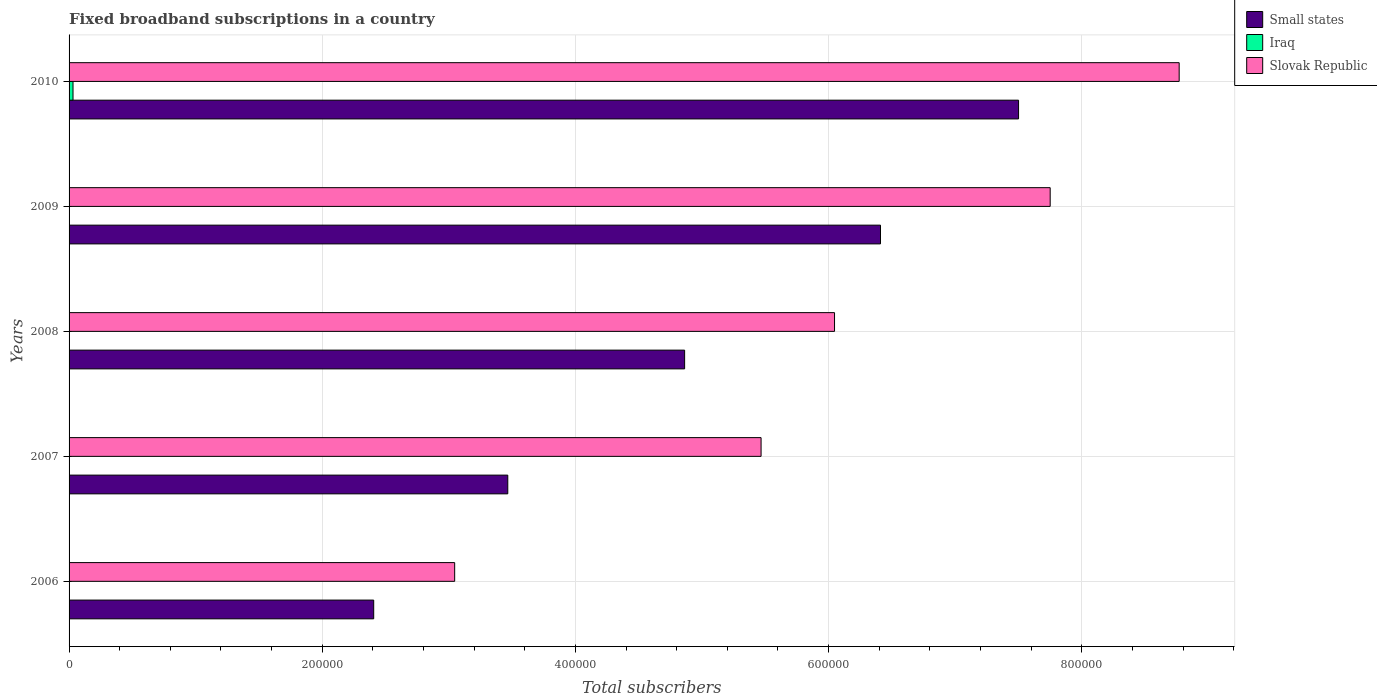How many different coloured bars are there?
Keep it short and to the point. 3. How many groups of bars are there?
Give a very brief answer. 5. Are the number of bars per tick equal to the number of legend labels?
Offer a terse response. Yes. What is the label of the 1st group of bars from the top?
Your response must be concise. 2010. In how many cases, is the number of bars for a given year not equal to the number of legend labels?
Your response must be concise. 0. What is the number of broadband subscriptions in Iraq in 2007?
Your answer should be compact. 98. Across all years, what is the maximum number of broadband subscriptions in Slovak Republic?
Make the answer very short. 8.77e+05. Across all years, what is the minimum number of broadband subscriptions in Slovak Republic?
Provide a succinct answer. 3.05e+05. In which year was the number of broadband subscriptions in Iraq maximum?
Provide a short and direct response. 2010. What is the total number of broadband subscriptions in Small states in the graph?
Make the answer very short. 2.46e+06. What is the difference between the number of broadband subscriptions in Slovak Republic in 2009 and that in 2010?
Your answer should be compact. -1.02e+05. What is the difference between the number of broadband subscriptions in Iraq in 2008 and the number of broadband subscriptions in Slovak Republic in 2007?
Offer a very short reply. -5.47e+05. What is the average number of broadband subscriptions in Iraq per year?
Your answer should be very brief. 683.2. In the year 2010, what is the difference between the number of broadband subscriptions in Slovak Republic and number of broadband subscriptions in Iraq?
Offer a terse response. 8.74e+05. In how many years, is the number of broadband subscriptions in Iraq greater than 880000 ?
Give a very brief answer. 0. What is the ratio of the number of broadband subscriptions in Iraq in 2006 to that in 2007?
Ensure brevity in your answer.  0.27. Is the difference between the number of broadband subscriptions in Slovak Republic in 2007 and 2009 greater than the difference between the number of broadband subscriptions in Iraq in 2007 and 2009?
Your answer should be compact. No. What is the difference between the highest and the second highest number of broadband subscriptions in Iraq?
Ensure brevity in your answer.  2996. What is the difference between the highest and the lowest number of broadband subscriptions in Iraq?
Keep it short and to the point. 3091. Is the sum of the number of broadband subscriptions in Slovak Republic in 2007 and 2008 greater than the maximum number of broadband subscriptions in Iraq across all years?
Offer a terse response. Yes. What does the 3rd bar from the top in 2006 represents?
Offer a terse response. Small states. What does the 3rd bar from the bottom in 2006 represents?
Offer a very short reply. Slovak Republic. How many years are there in the graph?
Your answer should be compact. 5. What is the difference between two consecutive major ticks on the X-axis?
Your response must be concise. 2.00e+05. Does the graph contain grids?
Offer a terse response. Yes. How many legend labels are there?
Offer a terse response. 3. What is the title of the graph?
Your answer should be compact. Fixed broadband subscriptions in a country. Does "Guinea-Bissau" appear as one of the legend labels in the graph?
Make the answer very short. No. What is the label or title of the X-axis?
Your response must be concise. Total subscribers. What is the Total subscribers of Small states in 2006?
Provide a short and direct response. 2.41e+05. What is the Total subscribers of Slovak Republic in 2006?
Give a very brief answer. 3.05e+05. What is the Total subscribers in Small states in 2007?
Offer a terse response. 3.47e+05. What is the Total subscribers of Iraq in 2007?
Provide a succinct answer. 98. What is the Total subscribers of Slovak Republic in 2007?
Provide a short and direct response. 5.47e+05. What is the Total subscribers in Small states in 2008?
Offer a terse response. 4.86e+05. What is the Total subscribers in Iraq in 2008?
Provide a succinct answer. 54. What is the Total subscribers in Slovak Republic in 2008?
Offer a very short reply. 6.05e+05. What is the Total subscribers of Small states in 2009?
Your answer should be compact. 6.41e+05. What is the Total subscribers of Iraq in 2009?
Your answer should be very brief. 121. What is the Total subscribers of Slovak Republic in 2009?
Keep it short and to the point. 7.75e+05. What is the Total subscribers of Small states in 2010?
Give a very brief answer. 7.50e+05. What is the Total subscribers in Iraq in 2010?
Offer a terse response. 3117. What is the Total subscribers of Slovak Republic in 2010?
Provide a succinct answer. 8.77e+05. Across all years, what is the maximum Total subscribers in Small states?
Your answer should be compact. 7.50e+05. Across all years, what is the maximum Total subscribers in Iraq?
Provide a succinct answer. 3117. Across all years, what is the maximum Total subscribers of Slovak Republic?
Your response must be concise. 8.77e+05. Across all years, what is the minimum Total subscribers in Small states?
Your answer should be very brief. 2.41e+05. Across all years, what is the minimum Total subscribers in Slovak Republic?
Provide a short and direct response. 3.05e+05. What is the total Total subscribers in Small states in the graph?
Your answer should be compact. 2.46e+06. What is the total Total subscribers in Iraq in the graph?
Your response must be concise. 3416. What is the total Total subscribers of Slovak Republic in the graph?
Provide a short and direct response. 3.11e+06. What is the difference between the Total subscribers of Small states in 2006 and that in 2007?
Provide a succinct answer. -1.06e+05. What is the difference between the Total subscribers in Iraq in 2006 and that in 2007?
Your answer should be very brief. -72. What is the difference between the Total subscribers in Slovak Republic in 2006 and that in 2007?
Your response must be concise. -2.42e+05. What is the difference between the Total subscribers of Small states in 2006 and that in 2008?
Provide a short and direct response. -2.46e+05. What is the difference between the Total subscribers of Iraq in 2006 and that in 2008?
Provide a succinct answer. -28. What is the difference between the Total subscribers of Slovak Republic in 2006 and that in 2008?
Your answer should be very brief. -3.00e+05. What is the difference between the Total subscribers of Small states in 2006 and that in 2009?
Keep it short and to the point. -4.00e+05. What is the difference between the Total subscribers in Iraq in 2006 and that in 2009?
Make the answer very short. -95. What is the difference between the Total subscribers of Slovak Republic in 2006 and that in 2009?
Provide a short and direct response. -4.70e+05. What is the difference between the Total subscribers of Small states in 2006 and that in 2010?
Provide a succinct answer. -5.09e+05. What is the difference between the Total subscribers in Iraq in 2006 and that in 2010?
Keep it short and to the point. -3091. What is the difference between the Total subscribers in Slovak Republic in 2006 and that in 2010?
Your answer should be very brief. -5.72e+05. What is the difference between the Total subscribers in Small states in 2007 and that in 2008?
Give a very brief answer. -1.40e+05. What is the difference between the Total subscribers in Iraq in 2007 and that in 2008?
Provide a succinct answer. 44. What is the difference between the Total subscribers of Slovak Republic in 2007 and that in 2008?
Make the answer very short. -5.80e+04. What is the difference between the Total subscribers of Small states in 2007 and that in 2009?
Make the answer very short. -2.94e+05. What is the difference between the Total subscribers in Iraq in 2007 and that in 2009?
Offer a terse response. -23. What is the difference between the Total subscribers in Slovak Republic in 2007 and that in 2009?
Your response must be concise. -2.28e+05. What is the difference between the Total subscribers in Small states in 2007 and that in 2010?
Your answer should be very brief. -4.04e+05. What is the difference between the Total subscribers in Iraq in 2007 and that in 2010?
Keep it short and to the point. -3019. What is the difference between the Total subscribers in Slovak Republic in 2007 and that in 2010?
Provide a short and direct response. -3.30e+05. What is the difference between the Total subscribers in Small states in 2008 and that in 2009?
Offer a very short reply. -1.55e+05. What is the difference between the Total subscribers of Iraq in 2008 and that in 2009?
Offer a terse response. -67. What is the difference between the Total subscribers of Slovak Republic in 2008 and that in 2009?
Offer a terse response. -1.70e+05. What is the difference between the Total subscribers of Small states in 2008 and that in 2010?
Provide a short and direct response. -2.64e+05. What is the difference between the Total subscribers in Iraq in 2008 and that in 2010?
Give a very brief answer. -3063. What is the difference between the Total subscribers in Slovak Republic in 2008 and that in 2010?
Provide a short and direct response. -2.72e+05. What is the difference between the Total subscribers in Small states in 2009 and that in 2010?
Make the answer very short. -1.09e+05. What is the difference between the Total subscribers of Iraq in 2009 and that in 2010?
Give a very brief answer. -2996. What is the difference between the Total subscribers in Slovak Republic in 2009 and that in 2010?
Offer a terse response. -1.02e+05. What is the difference between the Total subscribers in Small states in 2006 and the Total subscribers in Iraq in 2007?
Provide a succinct answer. 2.41e+05. What is the difference between the Total subscribers in Small states in 2006 and the Total subscribers in Slovak Republic in 2007?
Give a very brief answer. -3.06e+05. What is the difference between the Total subscribers in Iraq in 2006 and the Total subscribers in Slovak Republic in 2007?
Your response must be concise. -5.47e+05. What is the difference between the Total subscribers in Small states in 2006 and the Total subscribers in Iraq in 2008?
Your answer should be compact. 2.41e+05. What is the difference between the Total subscribers of Small states in 2006 and the Total subscribers of Slovak Republic in 2008?
Ensure brevity in your answer.  -3.64e+05. What is the difference between the Total subscribers in Iraq in 2006 and the Total subscribers in Slovak Republic in 2008?
Your answer should be very brief. -6.05e+05. What is the difference between the Total subscribers of Small states in 2006 and the Total subscribers of Iraq in 2009?
Offer a terse response. 2.41e+05. What is the difference between the Total subscribers of Small states in 2006 and the Total subscribers of Slovak Republic in 2009?
Give a very brief answer. -5.34e+05. What is the difference between the Total subscribers in Iraq in 2006 and the Total subscribers in Slovak Republic in 2009?
Your response must be concise. -7.75e+05. What is the difference between the Total subscribers of Small states in 2006 and the Total subscribers of Iraq in 2010?
Give a very brief answer. 2.38e+05. What is the difference between the Total subscribers of Small states in 2006 and the Total subscribers of Slovak Republic in 2010?
Provide a succinct answer. -6.36e+05. What is the difference between the Total subscribers of Iraq in 2006 and the Total subscribers of Slovak Republic in 2010?
Provide a succinct answer. -8.77e+05. What is the difference between the Total subscribers in Small states in 2007 and the Total subscribers in Iraq in 2008?
Your answer should be very brief. 3.47e+05. What is the difference between the Total subscribers in Small states in 2007 and the Total subscribers in Slovak Republic in 2008?
Your answer should be very brief. -2.58e+05. What is the difference between the Total subscribers in Iraq in 2007 and the Total subscribers in Slovak Republic in 2008?
Your answer should be compact. -6.05e+05. What is the difference between the Total subscribers of Small states in 2007 and the Total subscribers of Iraq in 2009?
Your response must be concise. 3.46e+05. What is the difference between the Total subscribers in Small states in 2007 and the Total subscribers in Slovak Republic in 2009?
Your answer should be compact. -4.28e+05. What is the difference between the Total subscribers of Iraq in 2007 and the Total subscribers of Slovak Republic in 2009?
Make the answer very short. -7.75e+05. What is the difference between the Total subscribers in Small states in 2007 and the Total subscribers in Iraq in 2010?
Provide a succinct answer. 3.43e+05. What is the difference between the Total subscribers in Small states in 2007 and the Total subscribers in Slovak Republic in 2010?
Offer a very short reply. -5.30e+05. What is the difference between the Total subscribers in Iraq in 2007 and the Total subscribers in Slovak Republic in 2010?
Make the answer very short. -8.77e+05. What is the difference between the Total subscribers of Small states in 2008 and the Total subscribers of Iraq in 2009?
Provide a succinct answer. 4.86e+05. What is the difference between the Total subscribers of Small states in 2008 and the Total subscribers of Slovak Republic in 2009?
Keep it short and to the point. -2.89e+05. What is the difference between the Total subscribers in Iraq in 2008 and the Total subscribers in Slovak Republic in 2009?
Your answer should be very brief. -7.75e+05. What is the difference between the Total subscribers in Small states in 2008 and the Total subscribers in Iraq in 2010?
Your response must be concise. 4.83e+05. What is the difference between the Total subscribers of Small states in 2008 and the Total subscribers of Slovak Republic in 2010?
Keep it short and to the point. -3.91e+05. What is the difference between the Total subscribers of Iraq in 2008 and the Total subscribers of Slovak Republic in 2010?
Keep it short and to the point. -8.77e+05. What is the difference between the Total subscribers of Small states in 2009 and the Total subscribers of Iraq in 2010?
Ensure brevity in your answer.  6.38e+05. What is the difference between the Total subscribers in Small states in 2009 and the Total subscribers in Slovak Republic in 2010?
Provide a short and direct response. -2.36e+05. What is the difference between the Total subscribers in Iraq in 2009 and the Total subscribers in Slovak Republic in 2010?
Your answer should be compact. -8.77e+05. What is the average Total subscribers in Small states per year?
Provide a succinct answer. 4.93e+05. What is the average Total subscribers of Iraq per year?
Make the answer very short. 683.2. What is the average Total subscribers of Slovak Republic per year?
Provide a succinct answer. 6.22e+05. In the year 2006, what is the difference between the Total subscribers in Small states and Total subscribers in Iraq?
Your response must be concise. 2.41e+05. In the year 2006, what is the difference between the Total subscribers of Small states and Total subscribers of Slovak Republic?
Provide a short and direct response. -6.40e+04. In the year 2006, what is the difference between the Total subscribers in Iraq and Total subscribers in Slovak Republic?
Offer a very short reply. -3.05e+05. In the year 2007, what is the difference between the Total subscribers in Small states and Total subscribers in Iraq?
Your response must be concise. 3.46e+05. In the year 2007, what is the difference between the Total subscribers of Small states and Total subscribers of Slovak Republic?
Offer a terse response. -2.00e+05. In the year 2007, what is the difference between the Total subscribers of Iraq and Total subscribers of Slovak Republic?
Offer a terse response. -5.47e+05. In the year 2008, what is the difference between the Total subscribers in Small states and Total subscribers in Iraq?
Provide a short and direct response. 4.86e+05. In the year 2008, what is the difference between the Total subscribers of Small states and Total subscribers of Slovak Republic?
Provide a succinct answer. -1.18e+05. In the year 2008, what is the difference between the Total subscribers of Iraq and Total subscribers of Slovak Republic?
Provide a short and direct response. -6.05e+05. In the year 2009, what is the difference between the Total subscribers in Small states and Total subscribers in Iraq?
Offer a terse response. 6.41e+05. In the year 2009, what is the difference between the Total subscribers in Small states and Total subscribers in Slovak Republic?
Provide a succinct answer. -1.34e+05. In the year 2009, what is the difference between the Total subscribers of Iraq and Total subscribers of Slovak Republic?
Your answer should be compact. -7.75e+05. In the year 2010, what is the difference between the Total subscribers of Small states and Total subscribers of Iraq?
Your answer should be very brief. 7.47e+05. In the year 2010, what is the difference between the Total subscribers in Small states and Total subscribers in Slovak Republic?
Give a very brief answer. -1.27e+05. In the year 2010, what is the difference between the Total subscribers in Iraq and Total subscribers in Slovak Republic?
Keep it short and to the point. -8.74e+05. What is the ratio of the Total subscribers in Small states in 2006 to that in 2007?
Make the answer very short. 0.69. What is the ratio of the Total subscribers in Iraq in 2006 to that in 2007?
Make the answer very short. 0.27. What is the ratio of the Total subscribers in Slovak Republic in 2006 to that in 2007?
Provide a short and direct response. 0.56. What is the ratio of the Total subscribers of Small states in 2006 to that in 2008?
Give a very brief answer. 0.49. What is the ratio of the Total subscribers of Iraq in 2006 to that in 2008?
Provide a succinct answer. 0.48. What is the ratio of the Total subscribers in Slovak Republic in 2006 to that in 2008?
Your answer should be compact. 0.5. What is the ratio of the Total subscribers of Small states in 2006 to that in 2009?
Offer a very short reply. 0.38. What is the ratio of the Total subscribers in Iraq in 2006 to that in 2009?
Your response must be concise. 0.21. What is the ratio of the Total subscribers in Slovak Republic in 2006 to that in 2009?
Your response must be concise. 0.39. What is the ratio of the Total subscribers of Small states in 2006 to that in 2010?
Give a very brief answer. 0.32. What is the ratio of the Total subscribers in Iraq in 2006 to that in 2010?
Offer a terse response. 0.01. What is the ratio of the Total subscribers of Slovak Republic in 2006 to that in 2010?
Your response must be concise. 0.35. What is the ratio of the Total subscribers in Small states in 2007 to that in 2008?
Provide a short and direct response. 0.71. What is the ratio of the Total subscribers of Iraq in 2007 to that in 2008?
Keep it short and to the point. 1.81. What is the ratio of the Total subscribers of Slovak Republic in 2007 to that in 2008?
Your answer should be very brief. 0.9. What is the ratio of the Total subscribers of Small states in 2007 to that in 2009?
Your answer should be compact. 0.54. What is the ratio of the Total subscribers of Iraq in 2007 to that in 2009?
Your response must be concise. 0.81. What is the ratio of the Total subscribers in Slovak Republic in 2007 to that in 2009?
Offer a very short reply. 0.71. What is the ratio of the Total subscribers of Small states in 2007 to that in 2010?
Offer a very short reply. 0.46. What is the ratio of the Total subscribers of Iraq in 2007 to that in 2010?
Ensure brevity in your answer.  0.03. What is the ratio of the Total subscribers in Slovak Republic in 2007 to that in 2010?
Give a very brief answer. 0.62. What is the ratio of the Total subscribers of Small states in 2008 to that in 2009?
Your response must be concise. 0.76. What is the ratio of the Total subscribers of Iraq in 2008 to that in 2009?
Provide a short and direct response. 0.45. What is the ratio of the Total subscribers of Slovak Republic in 2008 to that in 2009?
Your answer should be compact. 0.78. What is the ratio of the Total subscribers of Small states in 2008 to that in 2010?
Your response must be concise. 0.65. What is the ratio of the Total subscribers in Iraq in 2008 to that in 2010?
Offer a very short reply. 0.02. What is the ratio of the Total subscribers in Slovak Republic in 2008 to that in 2010?
Provide a succinct answer. 0.69. What is the ratio of the Total subscribers of Small states in 2009 to that in 2010?
Offer a very short reply. 0.85. What is the ratio of the Total subscribers of Iraq in 2009 to that in 2010?
Ensure brevity in your answer.  0.04. What is the ratio of the Total subscribers in Slovak Republic in 2009 to that in 2010?
Keep it short and to the point. 0.88. What is the difference between the highest and the second highest Total subscribers of Small states?
Give a very brief answer. 1.09e+05. What is the difference between the highest and the second highest Total subscribers in Iraq?
Give a very brief answer. 2996. What is the difference between the highest and the second highest Total subscribers in Slovak Republic?
Offer a terse response. 1.02e+05. What is the difference between the highest and the lowest Total subscribers in Small states?
Give a very brief answer. 5.09e+05. What is the difference between the highest and the lowest Total subscribers in Iraq?
Your answer should be very brief. 3091. What is the difference between the highest and the lowest Total subscribers in Slovak Republic?
Keep it short and to the point. 5.72e+05. 